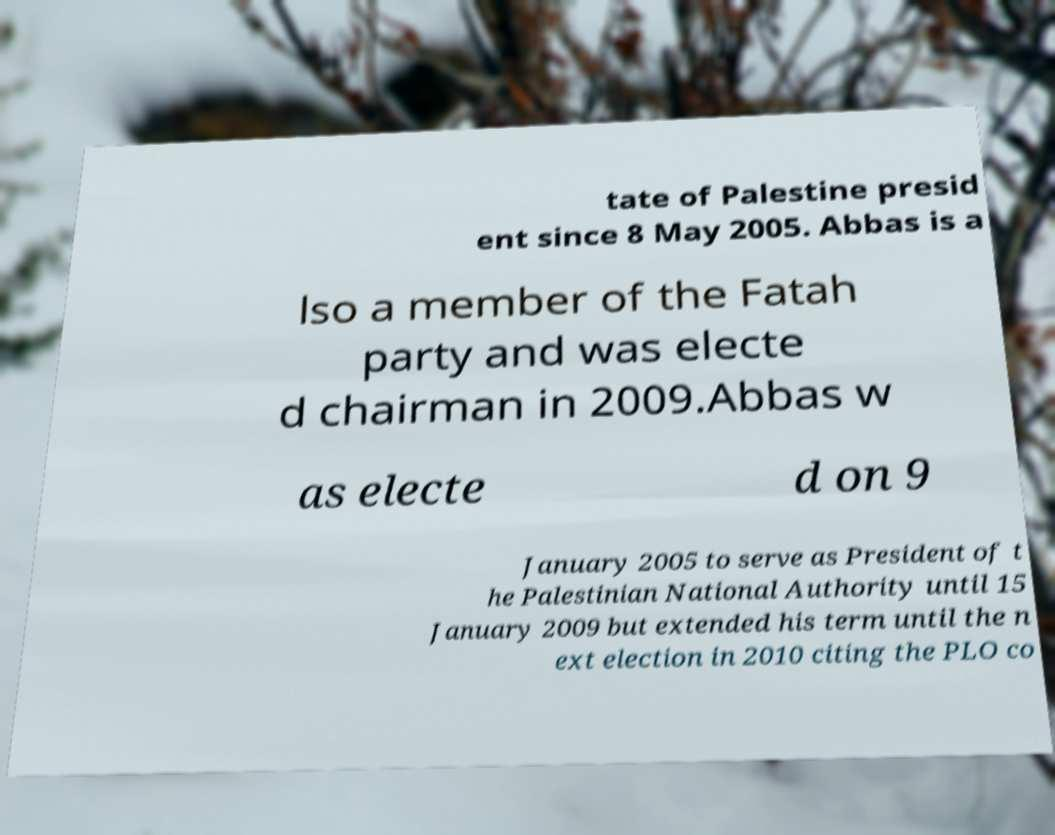There's text embedded in this image that I need extracted. Can you transcribe it verbatim? tate of Palestine presid ent since 8 May 2005. Abbas is a lso a member of the Fatah party and was electe d chairman in 2009.Abbas w as electe d on 9 January 2005 to serve as President of t he Palestinian National Authority until 15 January 2009 but extended his term until the n ext election in 2010 citing the PLO co 